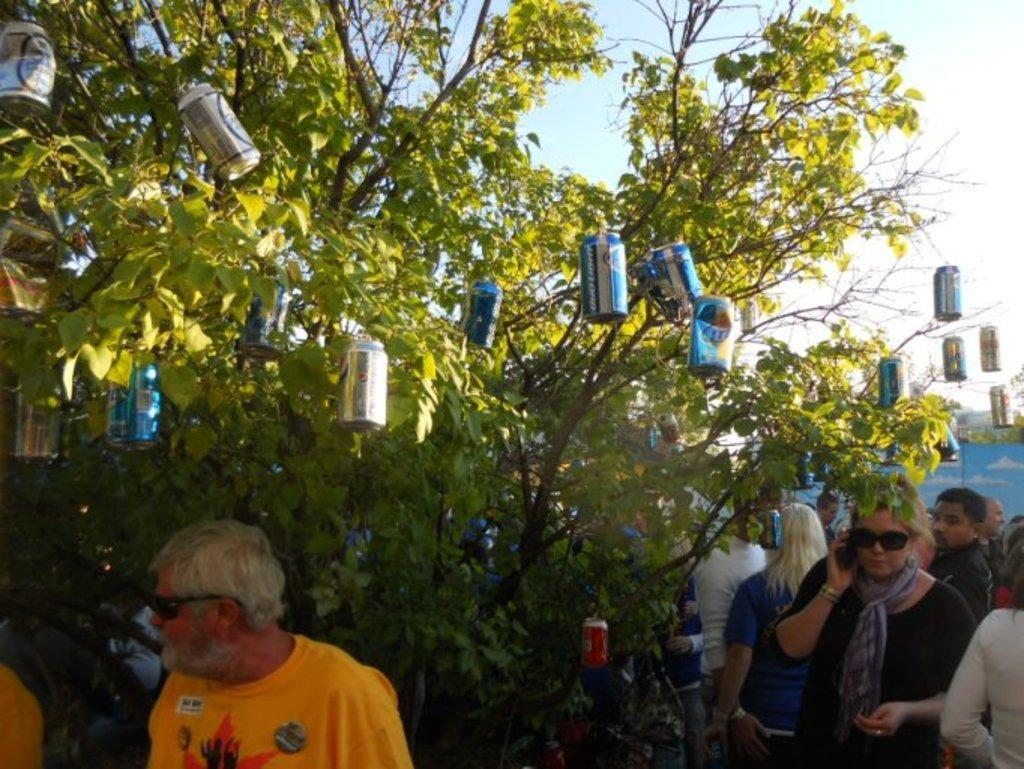How would you summarize this image in a sentence or two? In this image I can see few cock-tins which are hanging to the stems of a tree. At the bottom, I can see a crowd of people. At the top of the image I can see the sky. 